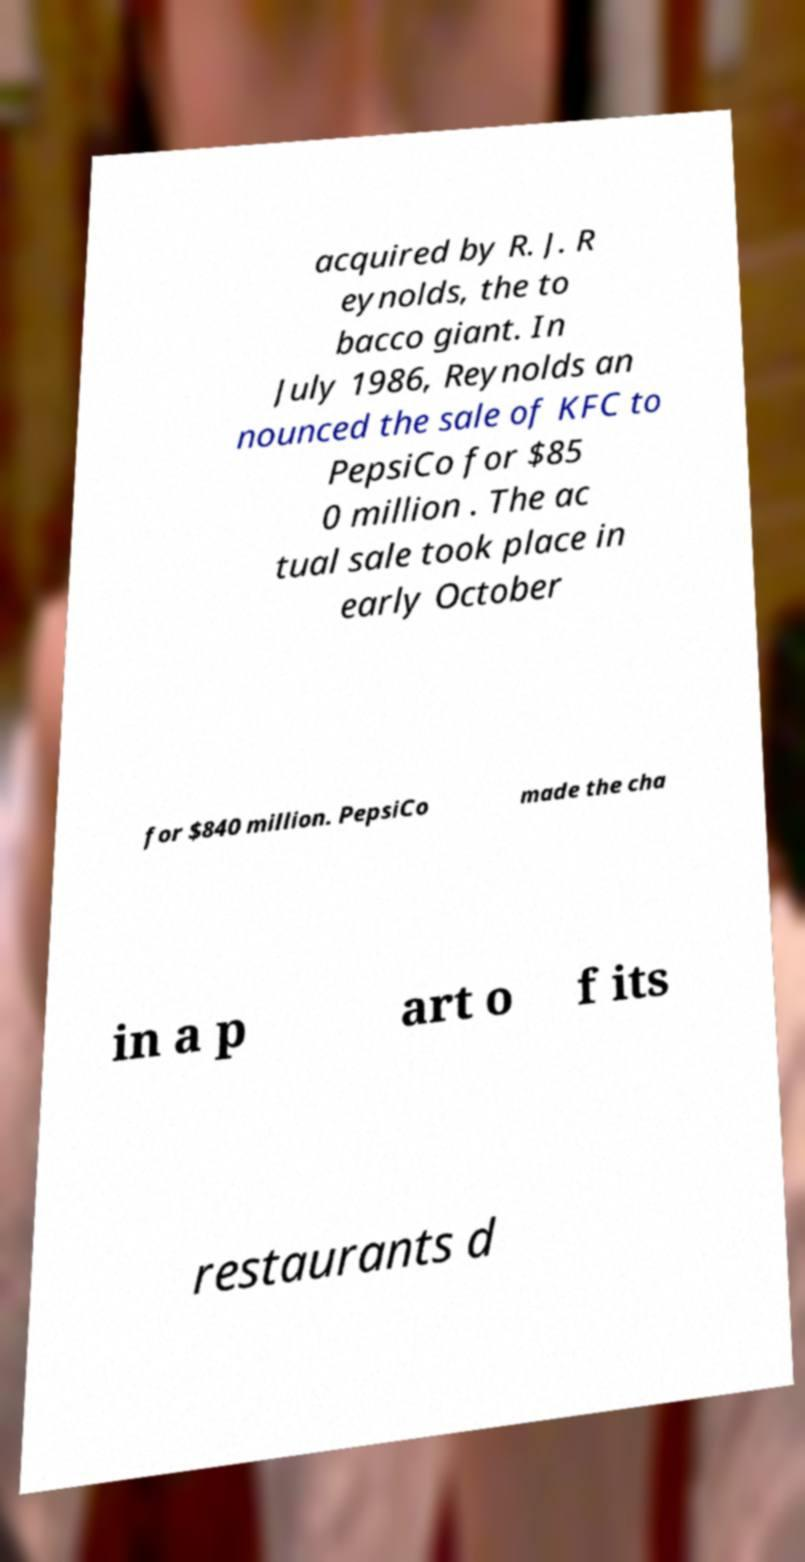Can you read and provide the text displayed in the image?This photo seems to have some interesting text. Can you extract and type it out for me? acquired by R. J. R eynolds, the to bacco giant. In July 1986, Reynolds an nounced the sale of KFC to PepsiCo for $85 0 million . The ac tual sale took place in early October for $840 million. PepsiCo made the cha in a p art o f its restaurants d 